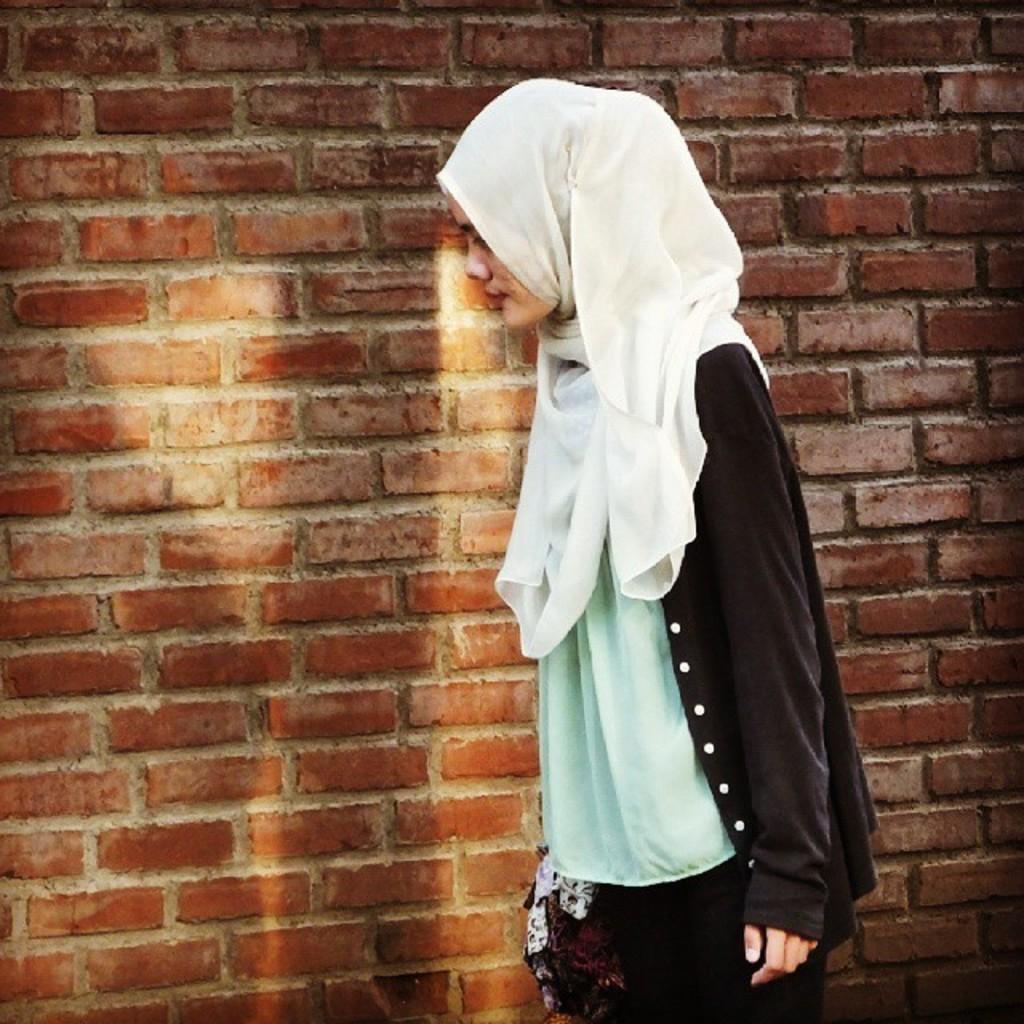Could you give a brief overview of what you see in this image? In the foreground of the picture there is a woman walking. In the background there is a brick wall. 